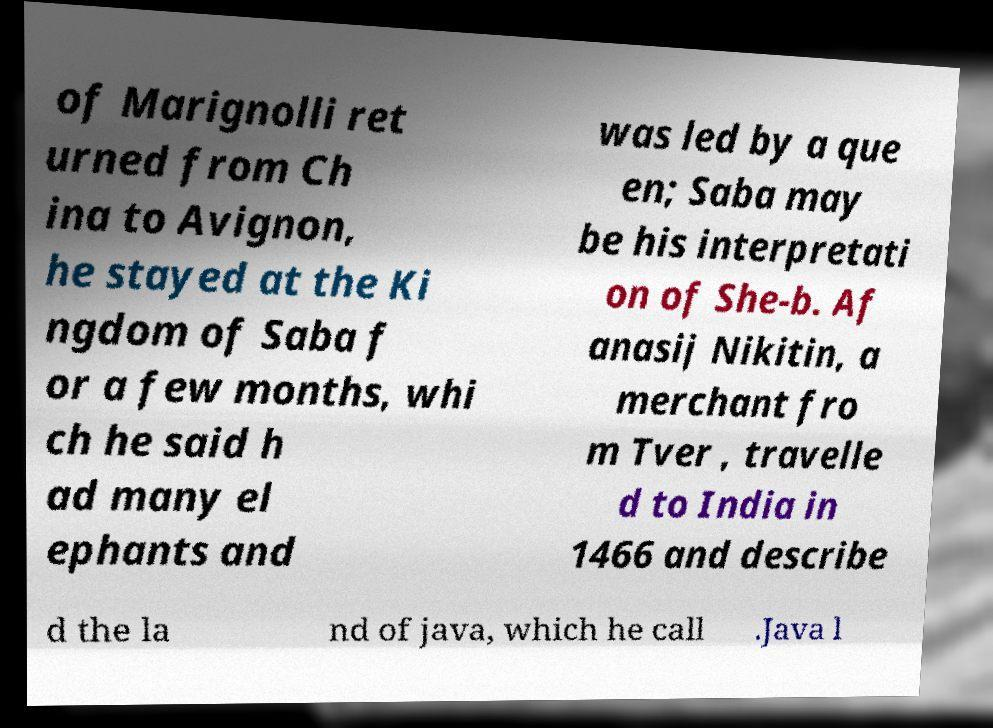Can you accurately transcribe the text from the provided image for me? of Marignolli ret urned from Ch ina to Avignon, he stayed at the Ki ngdom of Saba f or a few months, whi ch he said h ad many el ephants and was led by a que en; Saba may be his interpretati on of She-b. Af anasij Nikitin, a merchant fro m Tver , travelle d to India in 1466 and describe d the la nd of java, which he call .Java l 